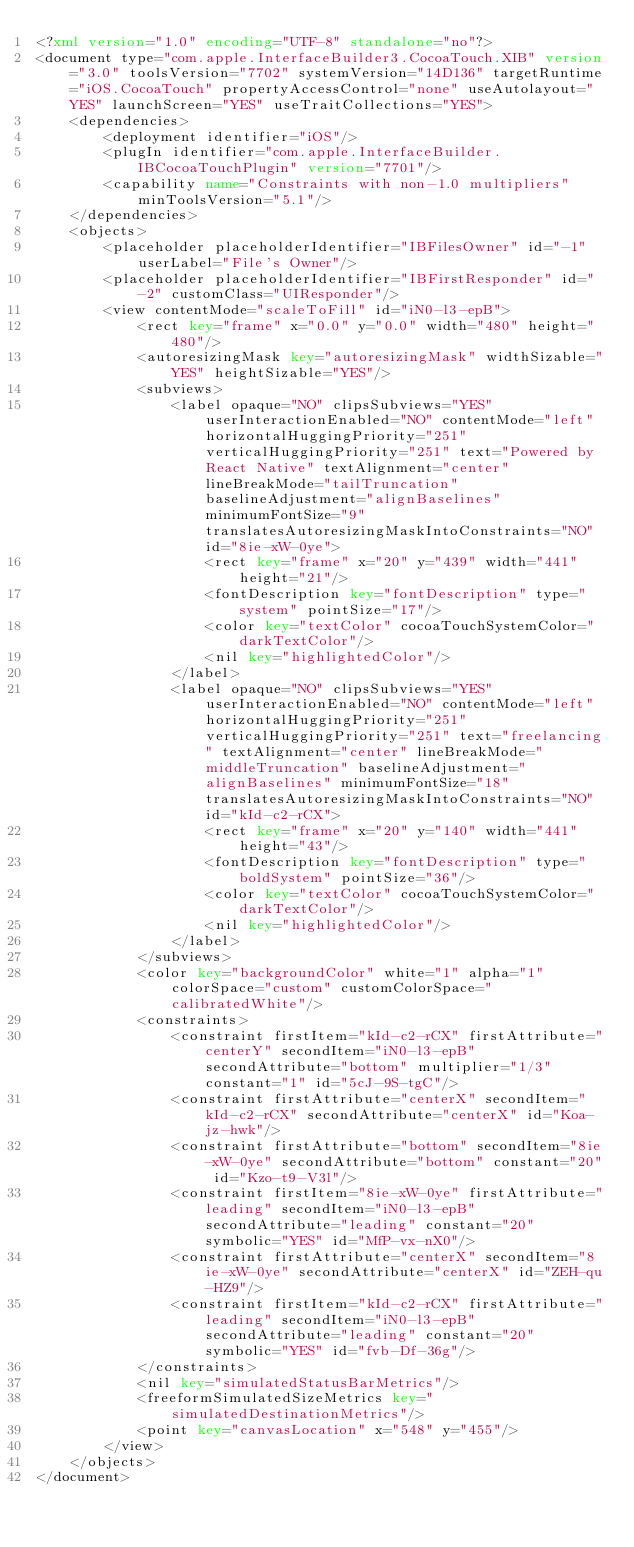Convert code to text. <code><loc_0><loc_0><loc_500><loc_500><_XML_><?xml version="1.0" encoding="UTF-8" standalone="no"?>
<document type="com.apple.InterfaceBuilder3.CocoaTouch.XIB" version="3.0" toolsVersion="7702" systemVersion="14D136" targetRuntime="iOS.CocoaTouch" propertyAccessControl="none" useAutolayout="YES" launchScreen="YES" useTraitCollections="YES">
    <dependencies>
        <deployment identifier="iOS"/>
        <plugIn identifier="com.apple.InterfaceBuilder.IBCocoaTouchPlugin" version="7701"/>
        <capability name="Constraints with non-1.0 multipliers" minToolsVersion="5.1"/>
    </dependencies>
    <objects>
        <placeholder placeholderIdentifier="IBFilesOwner" id="-1" userLabel="File's Owner"/>
        <placeholder placeholderIdentifier="IBFirstResponder" id="-2" customClass="UIResponder"/>
        <view contentMode="scaleToFill" id="iN0-l3-epB">
            <rect key="frame" x="0.0" y="0.0" width="480" height="480"/>
            <autoresizingMask key="autoresizingMask" widthSizable="YES" heightSizable="YES"/>
            <subviews>
                <label opaque="NO" clipsSubviews="YES" userInteractionEnabled="NO" contentMode="left" horizontalHuggingPriority="251" verticalHuggingPriority="251" text="Powered by React Native" textAlignment="center" lineBreakMode="tailTruncation" baselineAdjustment="alignBaselines" minimumFontSize="9" translatesAutoresizingMaskIntoConstraints="NO" id="8ie-xW-0ye">
                    <rect key="frame" x="20" y="439" width="441" height="21"/>
                    <fontDescription key="fontDescription" type="system" pointSize="17"/>
                    <color key="textColor" cocoaTouchSystemColor="darkTextColor"/>
                    <nil key="highlightedColor"/>
                </label>
                <label opaque="NO" clipsSubviews="YES" userInteractionEnabled="NO" contentMode="left" horizontalHuggingPriority="251" verticalHuggingPriority="251" text="freelancing" textAlignment="center" lineBreakMode="middleTruncation" baselineAdjustment="alignBaselines" minimumFontSize="18" translatesAutoresizingMaskIntoConstraints="NO" id="kId-c2-rCX">
                    <rect key="frame" x="20" y="140" width="441" height="43"/>
                    <fontDescription key="fontDescription" type="boldSystem" pointSize="36"/>
                    <color key="textColor" cocoaTouchSystemColor="darkTextColor"/>
                    <nil key="highlightedColor"/>
                </label>
            </subviews>
            <color key="backgroundColor" white="1" alpha="1" colorSpace="custom" customColorSpace="calibratedWhite"/>
            <constraints>
                <constraint firstItem="kId-c2-rCX" firstAttribute="centerY" secondItem="iN0-l3-epB" secondAttribute="bottom" multiplier="1/3" constant="1" id="5cJ-9S-tgC"/>
                <constraint firstAttribute="centerX" secondItem="kId-c2-rCX" secondAttribute="centerX" id="Koa-jz-hwk"/>
                <constraint firstAttribute="bottom" secondItem="8ie-xW-0ye" secondAttribute="bottom" constant="20" id="Kzo-t9-V3l"/>
                <constraint firstItem="8ie-xW-0ye" firstAttribute="leading" secondItem="iN0-l3-epB" secondAttribute="leading" constant="20" symbolic="YES" id="MfP-vx-nX0"/>
                <constraint firstAttribute="centerX" secondItem="8ie-xW-0ye" secondAttribute="centerX" id="ZEH-qu-HZ9"/>
                <constraint firstItem="kId-c2-rCX" firstAttribute="leading" secondItem="iN0-l3-epB" secondAttribute="leading" constant="20" symbolic="YES" id="fvb-Df-36g"/>
            </constraints>
            <nil key="simulatedStatusBarMetrics"/>
            <freeformSimulatedSizeMetrics key="simulatedDestinationMetrics"/>
            <point key="canvasLocation" x="548" y="455"/>
        </view>
    </objects>
</document>
</code> 